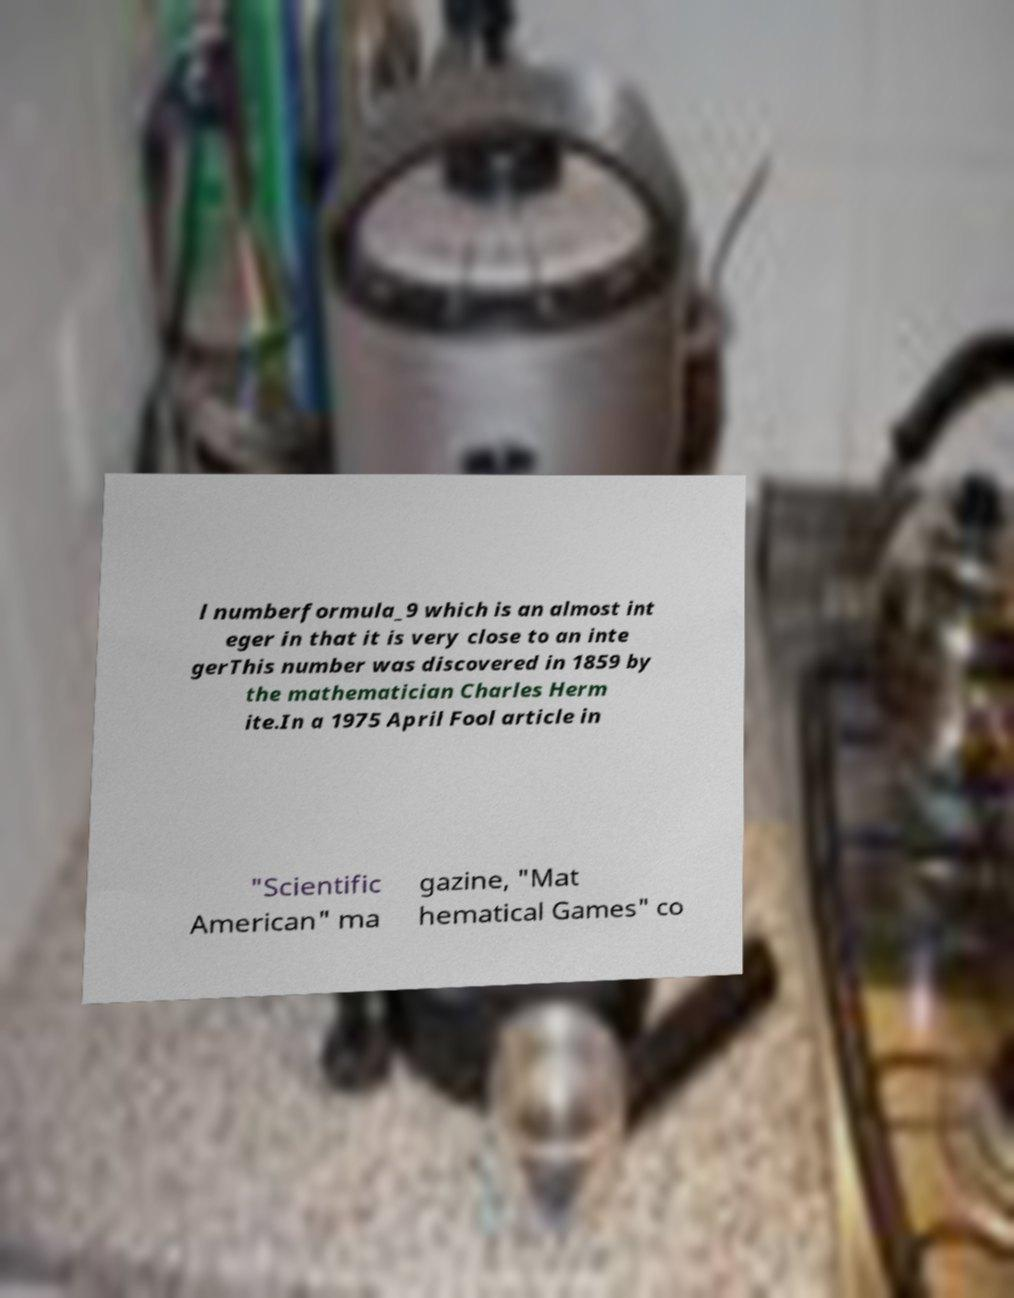Please identify and transcribe the text found in this image. l numberformula_9 which is an almost int eger in that it is very close to an inte gerThis number was discovered in 1859 by the mathematician Charles Herm ite.In a 1975 April Fool article in "Scientific American" ma gazine, "Mat hematical Games" co 